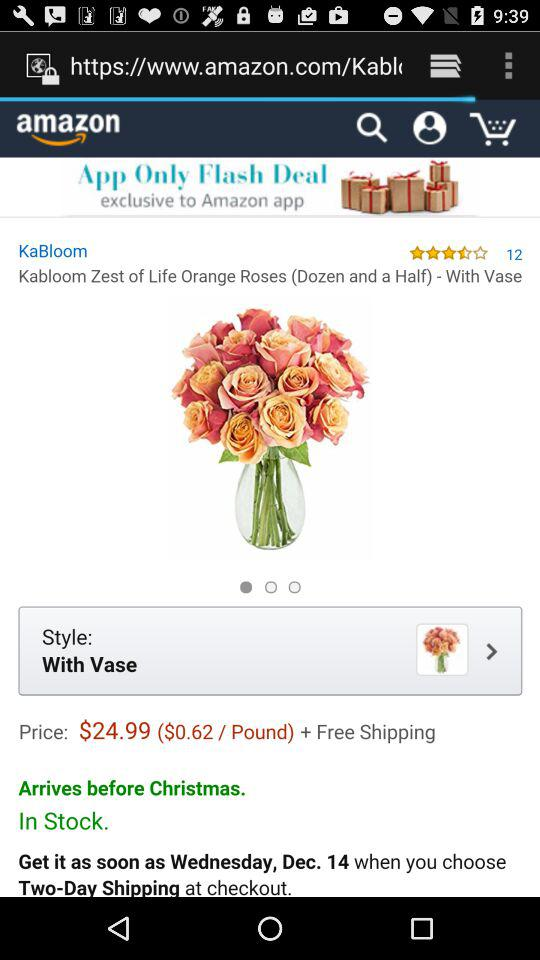What is the mentioned day and date? The mentioned day and date is Wednesday, 14th December. 